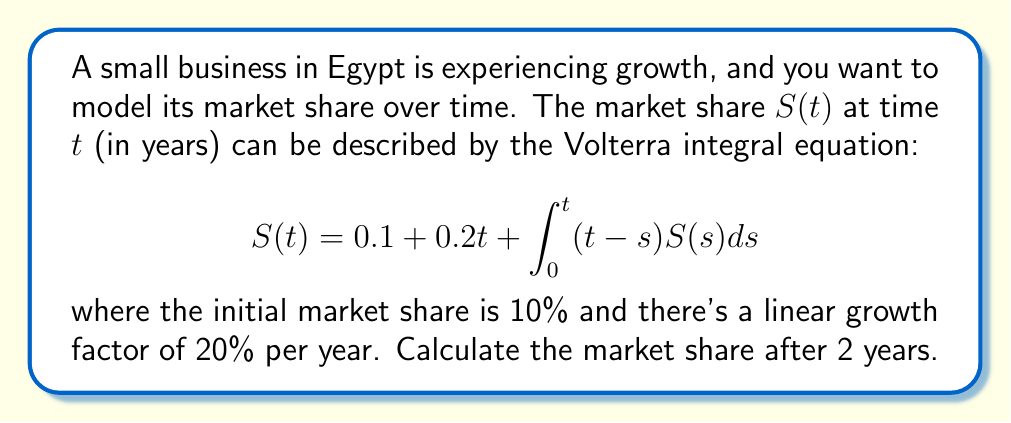Give your solution to this math problem. To solve this Volterra integral equation, we'll use the method of successive approximations:

1) Start with the initial approximation:
   $S_0(t) = 0.1 + 0.2t$

2) Substitute this into the integral equation to get the next approximation:
   $$S_1(t) = 0.1 + 0.2t + \int_0^t (t-s)(0.1 + 0.2s)ds$$

3) Evaluate the integral:
   $$\begin{align*}
   S_1(t) &= 0.1 + 0.2t + 0.1\int_0^t (t-s)ds + 0.2\int_0^t (t-s)sds \\
   &= 0.1 + 0.2t + 0.1[ts - \frac{s^2}{2}]_0^t + 0.2[ts^2 - \frac{s^3}{3}]_0^t \\
   &= 0.1 + 0.2t + 0.1(t^2 - \frac{t^2}{2}) + 0.2(t^3 - \frac{t^3}{3}) \\
   &= 0.1 + 0.2t + 0.05t^2 + \frac{1}{15}t^3
   \end{align*}$$

4) For $t = 2$:
   $$S_1(2) = 0.1 + 0.2(2) + 0.05(2^2) + \frac{1}{15}(2^3) = 0.1 + 0.4 + 0.2 + \frac{8}{15} \approx 1.2333$$

5) For a more accurate result, we could continue with more iterations, but this approximation is sufficient for our purposes.
Answer: $S(2) \approx 1.2333$ or $123.33\%$ 